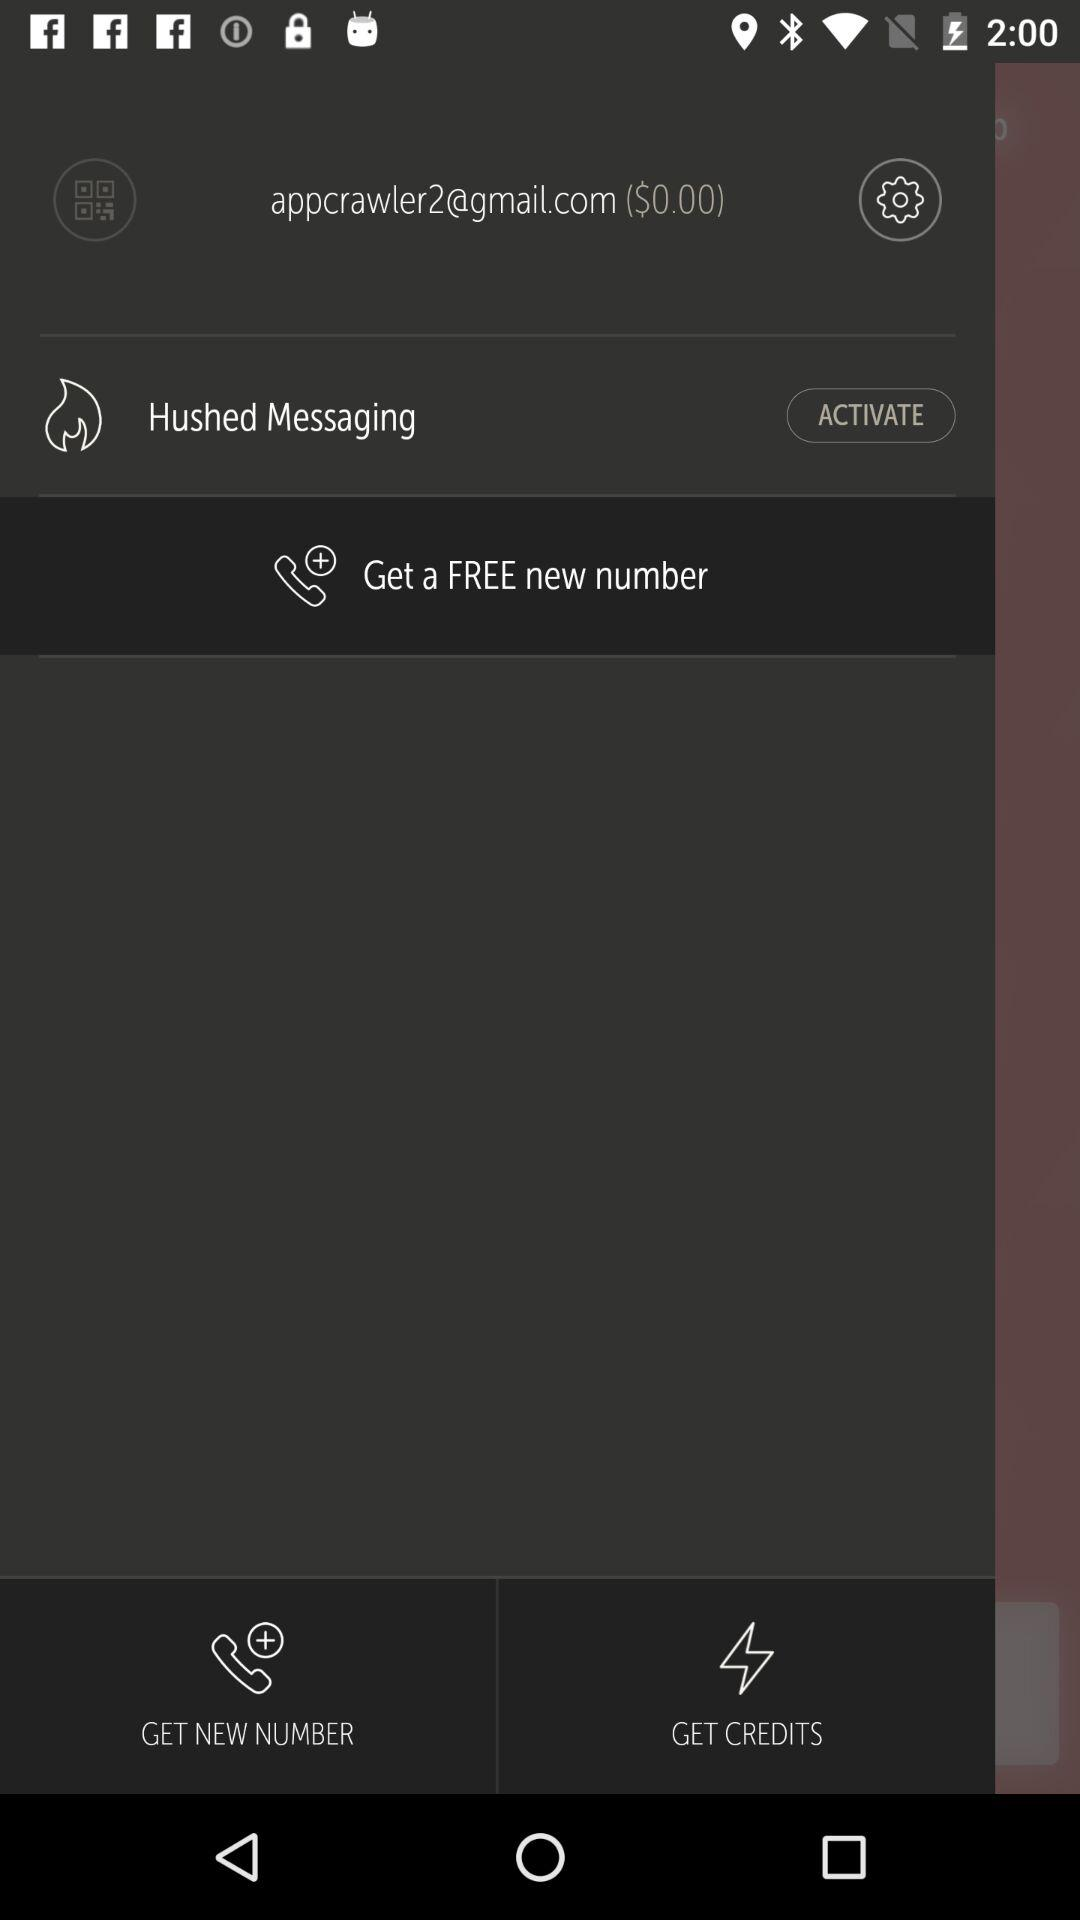What is the status of Hushed Messaging?
When the provided information is insufficient, respond with <no answer>. <no answer> 